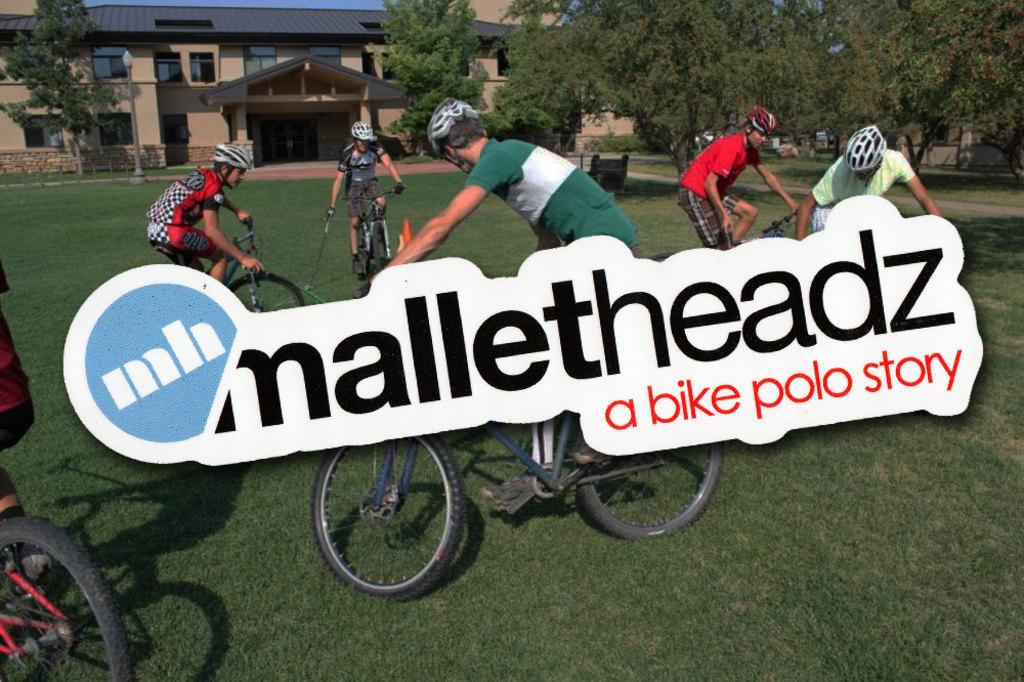What activity are the people in the image engaged in? The people in the image are cycling. What safety precaution are the cyclists taking? The people are wearing helmets. What can be seen in the background of the image? There are trees and a building in the background of the image. What type of feather can be seen on the cyclist's helmet in the image? There are no feathers present on the cyclists' helmets in the image. What is the zinc content of the building in the background? The zinc content of the building cannot be determined from the image. 